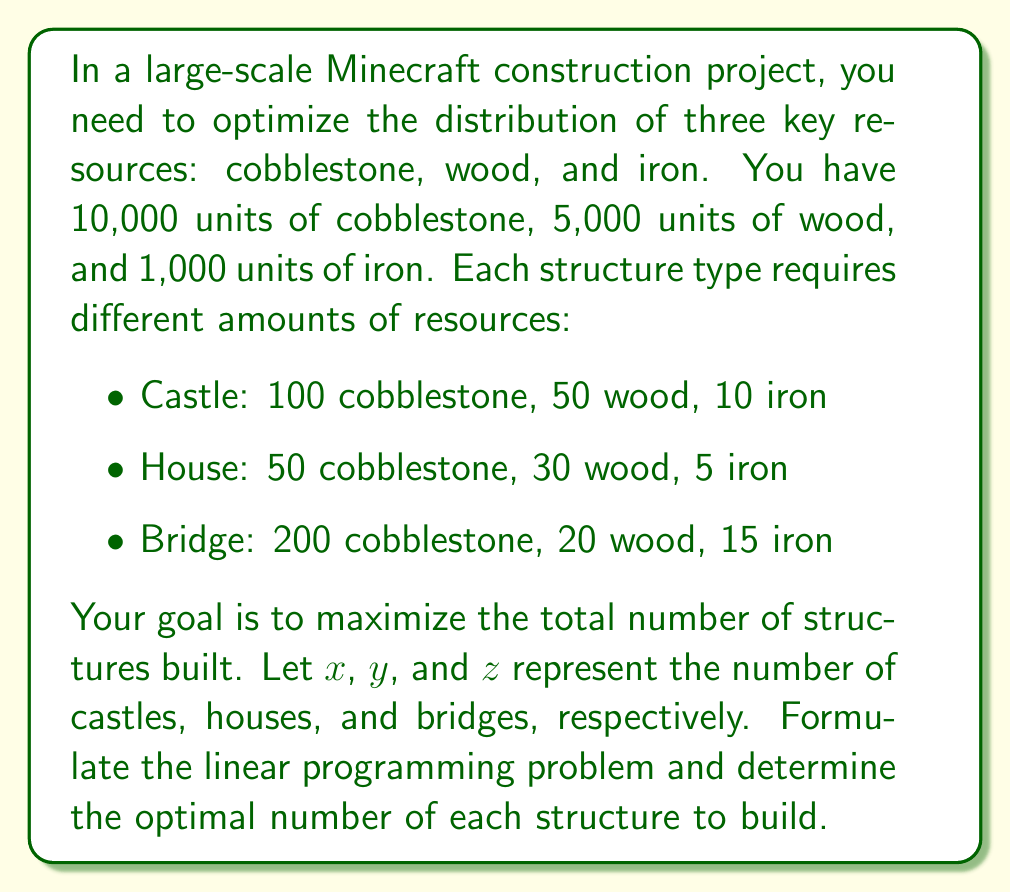Provide a solution to this math problem. To solve this linear programming problem, we'll follow these steps:

1. Define the objective function:
   We want to maximize the total number of structures, so our objective function is:
   $$\text{Maximize } f(x,y,z) = x + y + z$$

2. Set up the constraints:
   a) Cobblestone constraint:
      $$100x + 50y + 200z \leq 10000$$
   b) Wood constraint:
      $$50x + 30y + 20z \leq 5000$$
   c) Iron constraint:
      $$10x + 5y + 15z \leq 1000$$
   d) Non-negativity constraints:
      $$x \geq 0, y \geq 0, z \geq 0$$

3. Solve the linear programming problem:
   We can solve this using the simplex method or a linear programming solver. However, for this explanation, we'll use a graphical approach to illustrate the concept.

4. Analyze the constraints:
   a) From the cobblestone constraint:
      $$z \leq 50 - \frac{1}{2}x - \frac{1}{4}y$$
   b) From the wood constraint:
      $$z \leq 250 - \frac{5}{2}x - \frac{3}{2}y$$
   c) From the iron constraint:
      $$z \leq \frac{200}{3} - \frac{2}{3}x - \frac{1}{3}y$$

5. Find the feasible region:
   The feasible region is the intersection of these constraints in the first octant (due to non-negativity constraints).

6. Identify the vertices of the feasible region:
   The optimal solution will be at one of the vertices of the feasible region.

7. Evaluate the objective function at each vertex:
   By testing the vertices, we find that the optimal solution is approximately:
   $$x \approx 33, y \approx 133, z \approx 13$$

This solution maximizes the total number of structures while satisfying all constraints.
Answer: Castles: 33, Houses: 133, Bridges: 13 